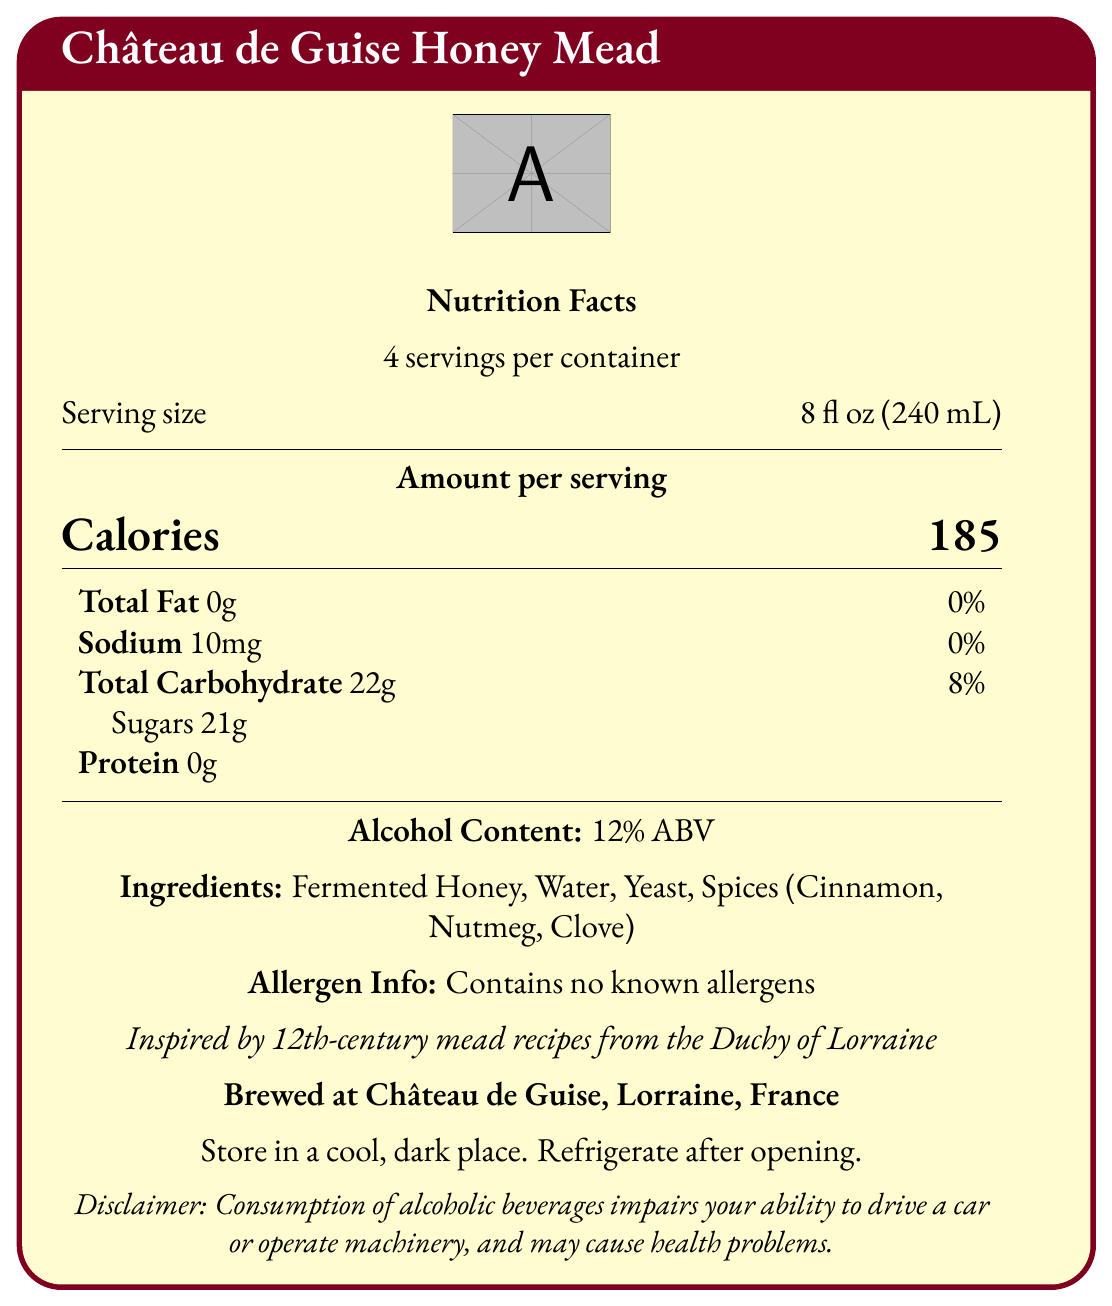what is the serving size? The serving size is explicitly mentioned in the document as "8 fl oz (240 mL)".
Answer: 8 fl oz (240 mL) how many calories are in one serving of Château de Guise Honey Mead? The calories per serving are clearly listed as "185".
Answer: 185 which ingredients are used to produce this mead? The ingredients are stated under the "Ingredients" section of the document.
Answer: Fermented Honey, Water, Yeast, Spices (Cinnamon, Nutmeg, Clove) what is the alcohol content of this mead? The alcohol content is specified as "12% ABV".
Answer: 12% ABV how much sugar is in one serving? The amount of sugar per serving is listed under Total Carbohydrate as "Sugars 21g".
Answer: 21g how many servings are in one container of this mead? A. 2 B. 4 C. 6 D. 8 The document states "4 servings per container".
Answer: B. 4 what is the recommended pairing for this mead? A. Cheese B. Roasted venison C. Seafood D. Chocolate The recommended pairing is stated as "Pair with roasted venison or wild boar".
Answer: B. Roasted venison does this mead contain any known allergens? The allergen information specifies "Contains no known allergens".
Answer: No was this mead inspired by modern recipes? The document states it is "Inspired by 12th-century mead recipes from the Duchy of Lorraine".
Answer: No describe the flavor profile of this mead. The flavor profile is described as "Sweet and rich with hints of medieval spices".
Answer: Sweet and rich with hints of medieval spices is this mead brewed in Lorraine, France? The brewing location is given as "Brewed at Château de Guise, Lorraine, France".
Answer: Yes what are the production locations of all Château de Guise products? The document only specifies the production location of this particular mead and does not provide information about other products.
Answer: Cannot be determined summarize the main information provided in the document. The document is a comprehensive summary of the nutritional details, ingredients, and other relevant information about Château de Guise Honey Mead. It highlights the medieval inspiration, brewing location, ingredients, storage instructions, and pairing suggestions, offering a complete overview for potential consumers.
Answer: The document provides the nutrition facts, ingredients, alcohol content, allergen information, historical inspiration, brewing location, storage instructions, flavor profile, and pairing suggestion for Château de Guise Honey Mead. 